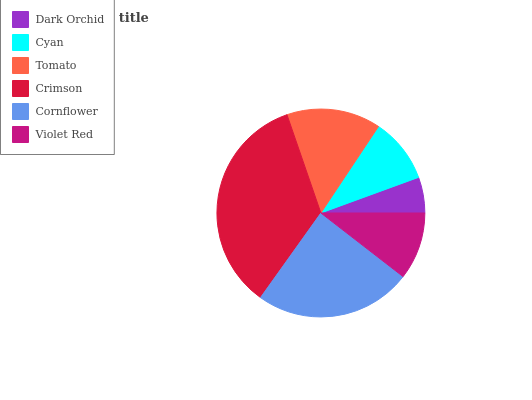Is Dark Orchid the minimum?
Answer yes or no. Yes. Is Crimson the maximum?
Answer yes or no. Yes. Is Cyan the minimum?
Answer yes or no. No. Is Cyan the maximum?
Answer yes or no. No. Is Cyan greater than Dark Orchid?
Answer yes or no. Yes. Is Dark Orchid less than Cyan?
Answer yes or no. Yes. Is Dark Orchid greater than Cyan?
Answer yes or no. No. Is Cyan less than Dark Orchid?
Answer yes or no. No. Is Tomato the high median?
Answer yes or no. Yes. Is Violet Red the low median?
Answer yes or no. Yes. Is Cyan the high median?
Answer yes or no. No. Is Crimson the low median?
Answer yes or no. No. 